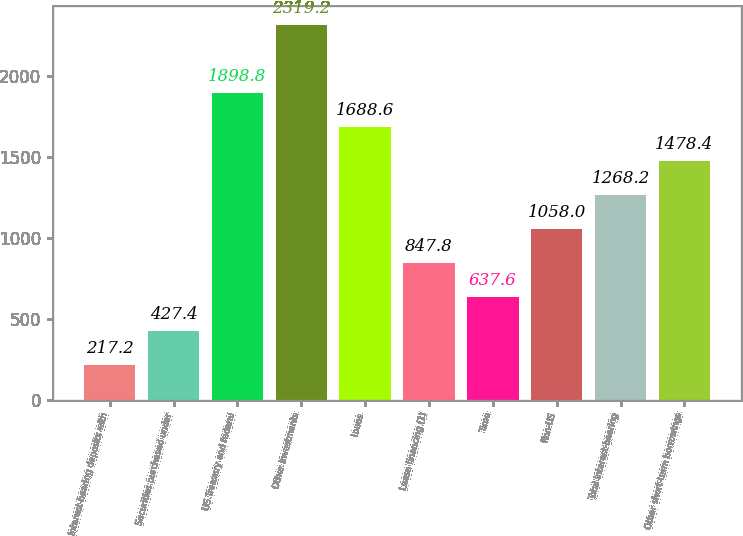Convert chart. <chart><loc_0><loc_0><loc_500><loc_500><bar_chart><fcel>Interest-bearing deposits with<fcel>Securities purchased under<fcel>US Treasury and federal<fcel>Other investments<fcel>Loans<fcel>Lease financing (1)<fcel>Time<fcel>Non-US<fcel>Total interest-bearing<fcel>Other short-term borrowings<nl><fcel>217.2<fcel>427.4<fcel>1898.8<fcel>2319.2<fcel>1688.6<fcel>847.8<fcel>637.6<fcel>1058<fcel>1268.2<fcel>1478.4<nl></chart> 